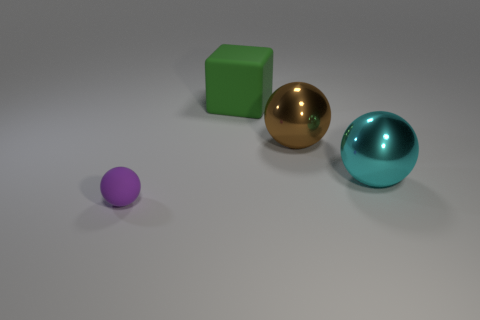What can you infer about the setting or location of these objects? The objects are placed on a neutral, flat surface with a soft shadow cast beneath each, which suggests a simple, controlled environment such as a photography studio setup or a 3D rendering scene with a single light source. Do the shadows indicate a specific time of day or type of lighting? The shadows are soft and diffused, which suggests the presence of either a softbox or other diffused artificial lighting typically used in photography studios, rather than direct sunlight which would cast sharper shadows and is indicative of outdoor lighting conditions. 